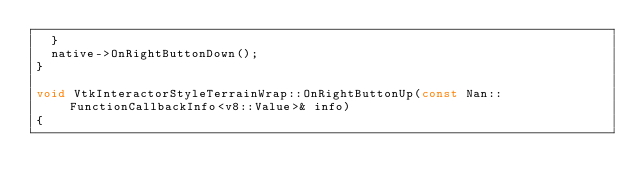Convert code to text. <code><loc_0><loc_0><loc_500><loc_500><_C++_>	}
	native->OnRightButtonDown();
}

void VtkInteractorStyleTerrainWrap::OnRightButtonUp(const Nan::FunctionCallbackInfo<v8::Value>& info)
{</code> 